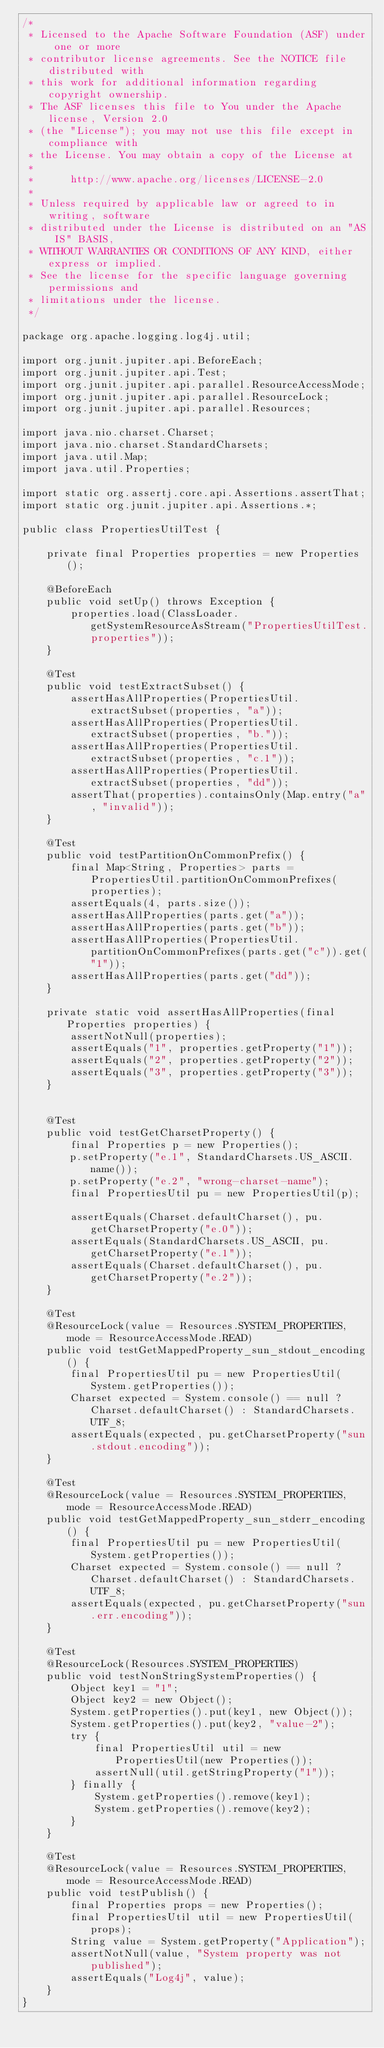<code> <loc_0><loc_0><loc_500><loc_500><_Java_>/*
 * Licensed to the Apache Software Foundation (ASF) under one or more
 * contributor license agreements. See the NOTICE file distributed with
 * this work for additional information regarding copyright ownership.
 * The ASF licenses this file to You under the Apache license, Version 2.0
 * (the "License"); you may not use this file except in compliance with
 * the License. You may obtain a copy of the License at
 *
 *      http://www.apache.org/licenses/LICENSE-2.0
 *
 * Unless required by applicable law or agreed to in writing, software
 * distributed under the License is distributed on an "AS IS" BASIS,
 * WITHOUT WARRANTIES OR CONDITIONS OF ANY KIND, either express or implied.
 * See the license for the specific language governing permissions and
 * limitations under the license.
 */

package org.apache.logging.log4j.util;

import org.junit.jupiter.api.BeforeEach;
import org.junit.jupiter.api.Test;
import org.junit.jupiter.api.parallel.ResourceAccessMode;
import org.junit.jupiter.api.parallel.ResourceLock;
import org.junit.jupiter.api.parallel.Resources;

import java.nio.charset.Charset;
import java.nio.charset.StandardCharsets;
import java.util.Map;
import java.util.Properties;

import static org.assertj.core.api.Assertions.assertThat;
import static org.junit.jupiter.api.Assertions.*;

public class PropertiesUtilTest {

    private final Properties properties = new Properties();

    @BeforeEach
    public void setUp() throws Exception {
        properties.load(ClassLoader.getSystemResourceAsStream("PropertiesUtilTest.properties"));
    }

    @Test
    public void testExtractSubset() {
        assertHasAllProperties(PropertiesUtil.extractSubset(properties, "a"));
        assertHasAllProperties(PropertiesUtil.extractSubset(properties, "b."));
        assertHasAllProperties(PropertiesUtil.extractSubset(properties, "c.1"));
        assertHasAllProperties(PropertiesUtil.extractSubset(properties, "dd"));
        assertThat(properties).containsOnly(Map.entry("a", "invalid"));
    }

    @Test
    public void testPartitionOnCommonPrefix() {
        final Map<String, Properties> parts = PropertiesUtil.partitionOnCommonPrefixes(properties);
        assertEquals(4, parts.size());
        assertHasAllProperties(parts.get("a"));
        assertHasAllProperties(parts.get("b"));
        assertHasAllProperties(PropertiesUtil.partitionOnCommonPrefixes(parts.get("c")).get("1"));
        assertHasAllProperties(parts.get("dd"));
    }

    private static void assertHasAllProperties(final Properties properties) {
        assertNotNull(properties);
        assertEquals("1", properties.getProperty("1"));
        assertEquals("2", properties.getProperty("2"));
        assertEquals("3", properties.getProperty("3"));
    }


    @Test
    public void testGetCharsetProperty() {
        final Properties p = new Properties();
        p.setProperty("e.1", StandardCharsets.US_ASCII.name());
        p.setProperty("e.2", "wrong-charset-name");
        final PropertiesUtil pu = new PropertiesUtil(p);

        assertEquals(Charset.defaultCharset(), pu.getCharsetProperty("e.0"));
        assertEquals(StandardCharsets.US_ASCII, pu.getCharsetProperty("e.1"));
        assertEquals(Charset.defaultCharset(), pu.getCharsetProperty("e.2"));
    }
    
    @Test
    @ResourceLock(value = Resources.SYSTEM_PROPERTIES, mode = ResourceAccessMode.READ)
    public void testGetMappedProperty_sun_stdout_encoding() {
        final PropertiesUtil pu = new PropertiesUtil(System.getProperties());
        Charset expected = System.console() == null ? Charset.defaultCharset() : StandardCharsets.UTF_8;
        assertEquals(expected, pu.getCharsetProperty("sun.stdout.encoding"));
    }

    @Test
    @ResourceLock(value = Resources.SYSTEM_PROPERTIES, mode = ResourceAccessMode.READ)
    public void testGetMappedProperty_sun_stderr_encoding() {
        final PropertiesUtil pu = new PropertiesUtil(System.getProperties());
        Charset expected = System.console() == null ? Charset.defaultCharset() : StandardCharsets.UTF_8;
        assertEquals(expected, pu.getCharsetProperty("sun.err.encoding"));
    }

    @Test
    @ResourceLock(Resources.SYSTEM_PROPERTIES)
    public void testNonStringSystemProperties() {
        Object key1 = "1";
        Object key2 = new Object();
        System.getProperties().put(key1, new Object());
        System.getProperties().put(key2, "value-2");
        try {
            final PropertiesUtil util = new PropertiesUtil(new Properties());
            assertNull(util.getStringProperty("1"));
        } finally {
            System.getProperties().remove(key1);
            System.getProperties().remove(key2);
        }
    }

    @Test
    @ResourceLock(value = Resources.SYSTEM_PROPERTIES, mode = ResourceAccessMode.READ)
    public void testPublish() {
        final Properties props = new Properties();
        final PropertiesUtil util = new PropertiesUtil(props);
        String value = System.getProperty("Application");
        assertNotNull(value, "System property was not published");
        assertEquals("Log4j", value);
    }
}
</code> 